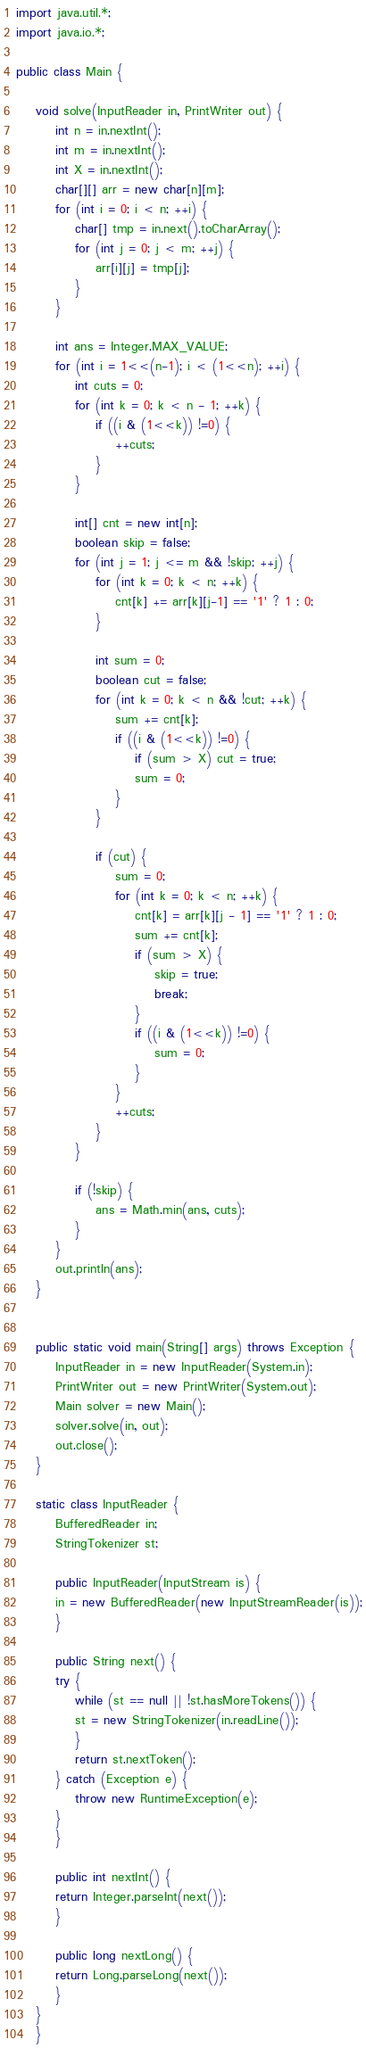Convert code to text. <code><loc_0><loc_0><loc_500><loc_500><_Java_>import java.util.*;
import java.io.*;

public class Main {
    
    void solve(InputReader in, PrintWriter out) {
        int n = in.nextInt();
        int m = in.nextInt();
        int X = in.nextInt();
        char[][] arr = new char[n][m];
        for (int i = 0; i < n; ++i) {
            char[] tmp = in.next().toCharArray();
            for (int j = 0; j < m; ++j) {
                arr[i][j] = tmp[j];
            }
        }

        int ans = Integer.MAX_VALUE;
        for (int i = 1<<(n-1); i < (1<<n); ++i) {
            int cuts = 0;
            for (int k = 0; k < n - 1; ++k) {
                if ((i & (1<<k)) !=0) {
                    ++cuts;
                }
            }

            int[] cnt = new int[n];
            boolean skip = false;
            for (int j = 1; j <= m && !skip; ++j) {
                for (int k = 0; k < n; ++k) {
                    cnt[k] += arr[k][j-1] == '1' ? 1 : 0;
                }

                int sum = 0;
                boolean cut = false;
                for (int k = 0; k < n && !cut; ++k) {
                    sum += cnt[k];
                    if ((i & (1<<k)) !=0) {
                        if (sum > X) cut = true;
                        sum = 0;
                    }
                }

                if (cut) {
                    sum = 0;
                    for (int k = 0; k < n; ++k) {
                        cnt[k] = arr[k][j - 1] == '1' ? 1 : 0;
                        sum += cnt[k];
                        if (sum > X) {
                            skip = true;
                            break;
                        }
                        if ((i & (1<<k)) !=0) {
                            sum = 0;
                        }
                    }
                    ++cuts;
                }
            }

            if (!skip) {
                ans = Math.min(ans, cuts);
            }
        }
        out.println(ans);
    }


    public static void main(String[] args) throws Exception {
        InputReader in = new InputReader(System.in);
        PrintWriter out = new PrintWriter(System.out);
        Main solver = new Main();
        solver.solve(in, out);
        out.close();
    }

    static class InputReader {
        BufferedReader in;
        StringTokenizer st;

        public InputReader(InputStream is) {
        in = new BufferedReader(new InputStreamReader(is));
        }

        public String next() {
        try {
            while (st == null || !st.hasMoreTokens()) {
            st = new StringTokenizer(in.readLine());
            }
            return st.nextToken();
        } catch (Exception e) {
            throw new RuntimeException(e);
        }
        }

        public int nextInt() {
        return Integer.parseInt(next());
        }

        public long nextLong() {
        return Long.parseLong(next());
        }
    }
    }
</code> 